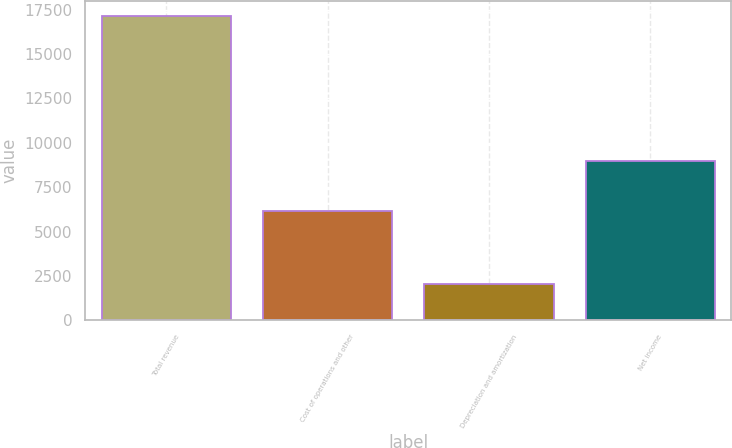Convert chart to OTSL. <chart><loc_0><loc_0><loc_500><loc_500><bar_chart><fcel>Total revenue<fcel>Cost of operations and other<fcel>Depreciation and amortization<fcel>Net income<nl><fcel>17154<fcel>6159<fcel>2023<fcel>8972<nl></chart> 